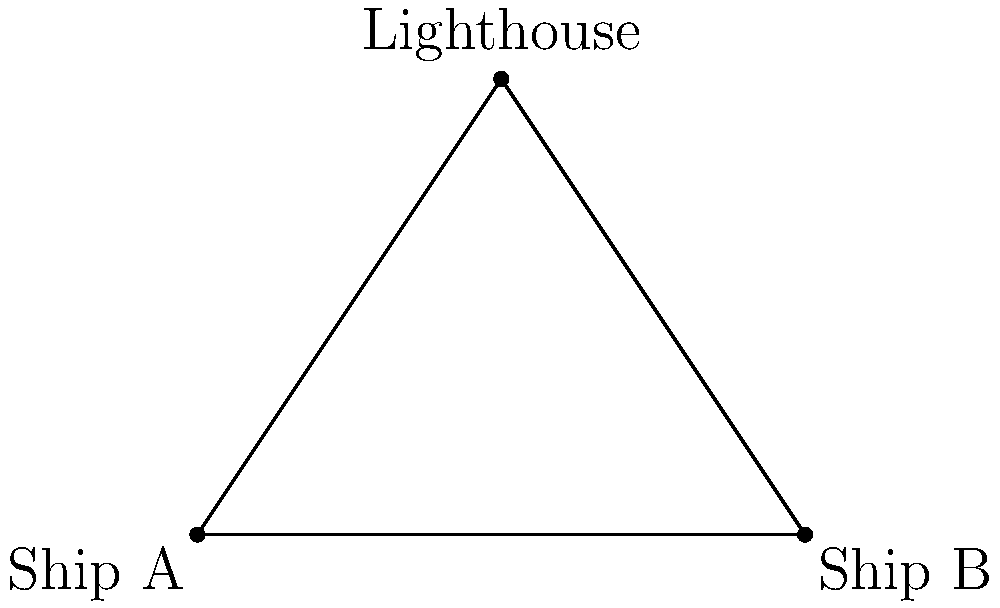As a loyal listener of your favorite radio show, you've been inspired to support a local maritime business. The owner mentions a trigonometry problem they encountered: Two ships, A and B, are positioned relative to a lighthouse. Ship A is 6 km west of the lighthouse, while Ship B is 6 km east of it. If the angle between the two ships from the lighthouse's perspective is 90°, what is the distance between the two ships? Let's approach this step-by-step:

1) We can visualize this scenario as a right-angled triangle, where:
   - The lighthouse is at the right angle
   - Ships A and B are at the other two corners
   - The distance between the ships is the hypotenuse

2) We know that:
   - The distance from the lighthouse to each ship is 6 km
   - The angle at the lighthouse is 90°

3) This forms an isosceles right triangle, where the two legs are equal (both 6 km) and the angle between them is 90°.

4) To find the distance between the ships, we need to calculate the length of the hypotenuse.

5) We can use the Pythagorean theorem: $a^2 + b^2 = c^2$
   Where $c$ is the hypotenuse (the distance we're looking for), and $a$ and $b$ are the other two sides.

6) Plugging in the values:
   $6^2 + 6^2 = c^2$
   $36 + 36 = c^2$
   $72 = c^2$

7) Taking the square root of both sides:
   $\sqrt{72} = c$
   $6\sqrt{2} \approx 8.49$ km

Therefore, the distance between the two ships is $6\sqrt{2}$ km or approximately 8.49 km.
Answer: $6\sqrt{2}$ km 